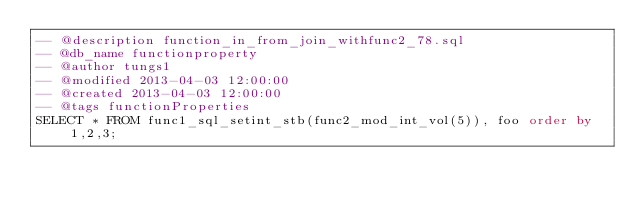Convert code to text. <code><loc_0><loc_0><loc_500><loc_500><_SQL_>-- @description function_in_from_join_withfunc2_78.sql
-- @db_name functionproperty
-- @author tungs1
-- @modified 2013-04-03 12:00:00
-- @created 2013-04-03 12:00:00
-- @tags functionProperties 
SELECT * FROM func1_sql_setint_stb(func2_mod_int_vol(5)), foo order by 1,2,3; 
</code> 